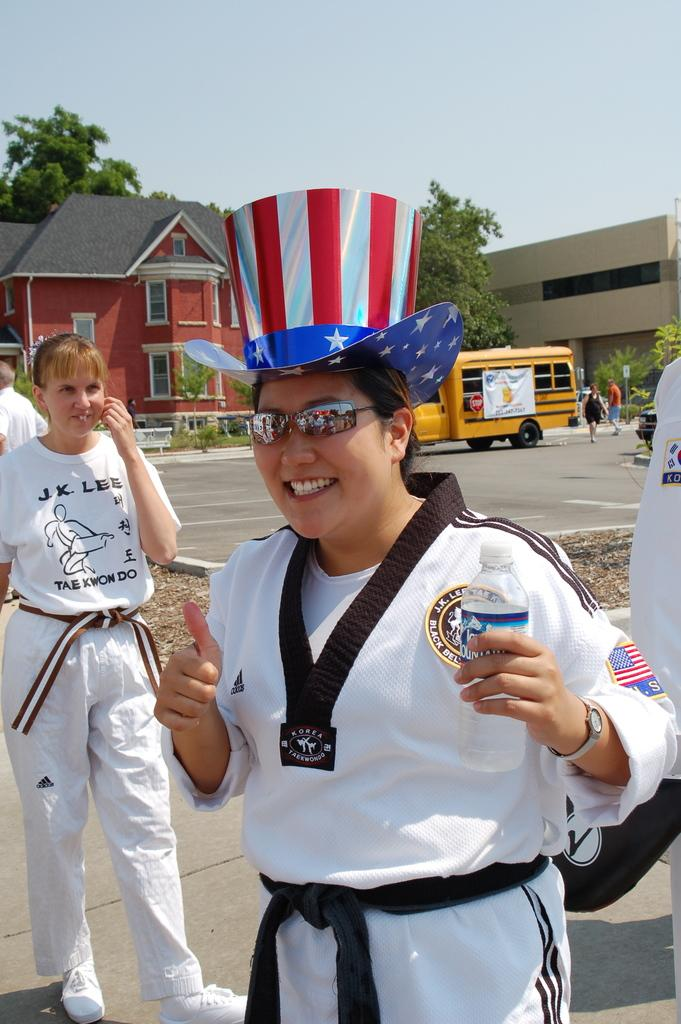<image>
Render a clear and concise summary of the photo. A woman wearing a patriotic hat wears a black belt with Korea Taekwondo written on it 